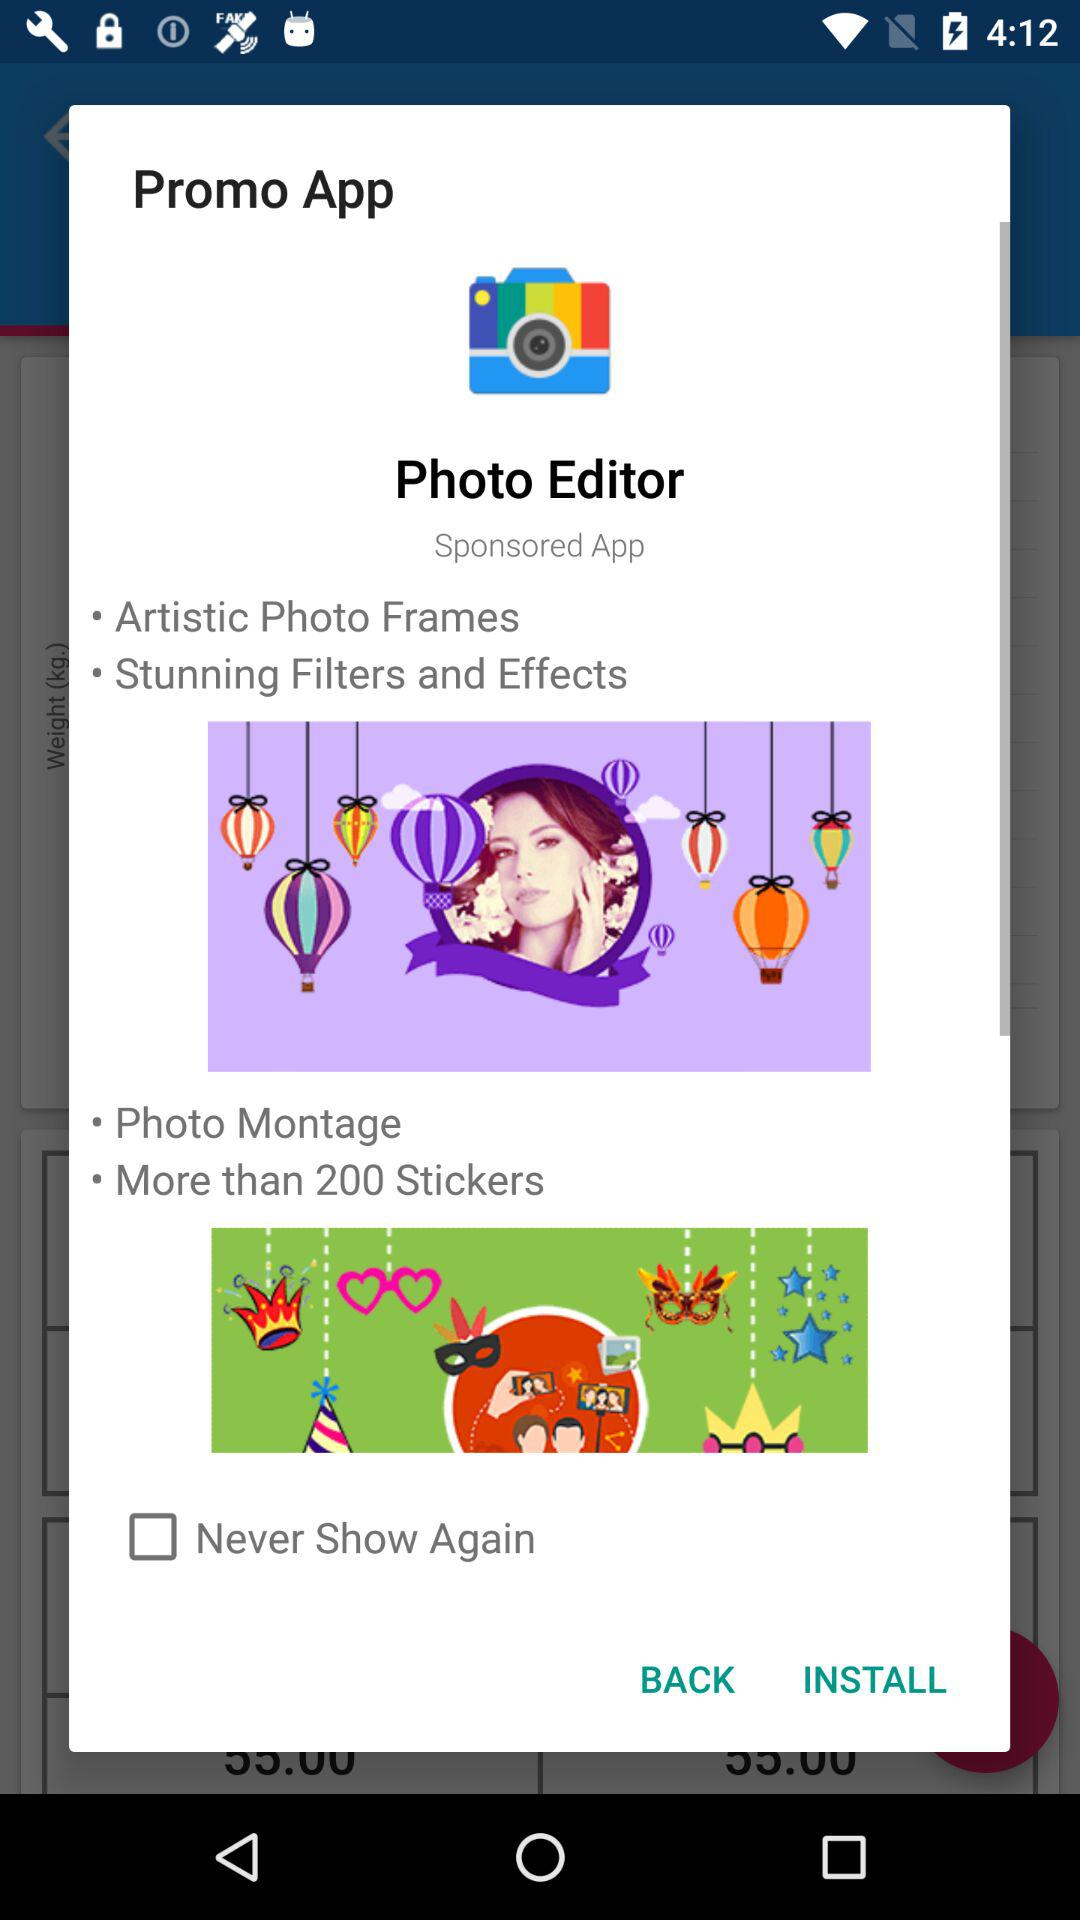What is the status of "Never Show Again"? The status of "Never Show Again" is "off". 